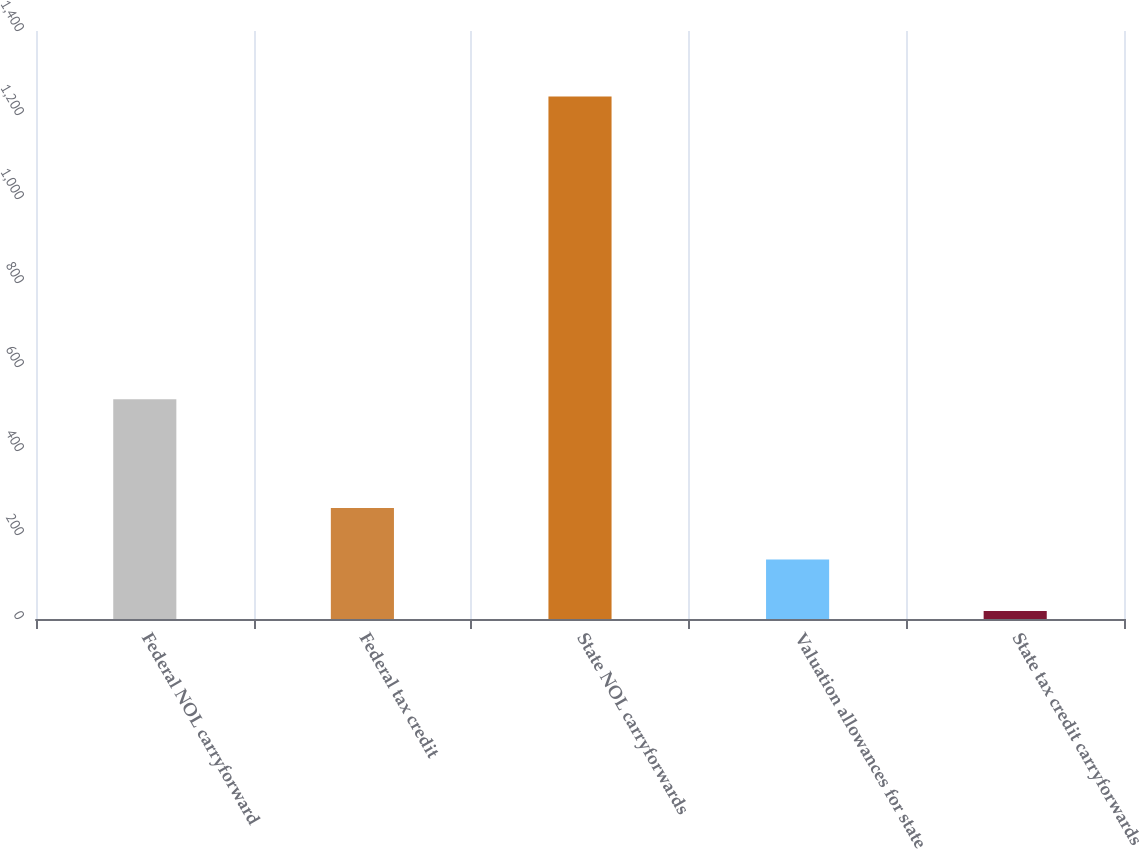<chart> <loc_0><loc_0><loc_500><loc_500><bar_chart><fcel>Federal NOL carryforward<fcel>Federal tax credit<fcel>State NOL carryforwards<fcel>Valuation allowances for state<fcel>State tax credit carryforwards<nl><fcel>523<fcel>264<fcel>1244<fcel>141.5<fcel>19<nl></chart> 